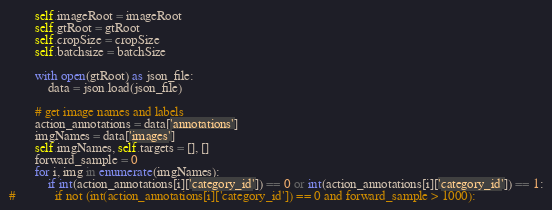<code> <loc_0><loc_0><loc_500><loc_500><_Python_>
        self.imageRoot = imageRoot
        self.gtRoot = gtRoot
        self.cropSize = cropSize
        self.batchsize = batchSize

        with open(gtRoot) as json_file:
            data = json.load(json_file)

        # get image names and labels
        action_annotations = data['annotations']
        imgNames = data['images']
        self.imgNames, self.targets = [], []
        forward_sample = 0
        for i, img in enumerate(imgNames):
            if int(action_annotations[i]['category_id']) == 0 or int(action_annotations[i]['category_id']) == 1:
#            if not (int(action_annotations[i]['category_id']) == 0 and forward_sample > 1000):</code> 